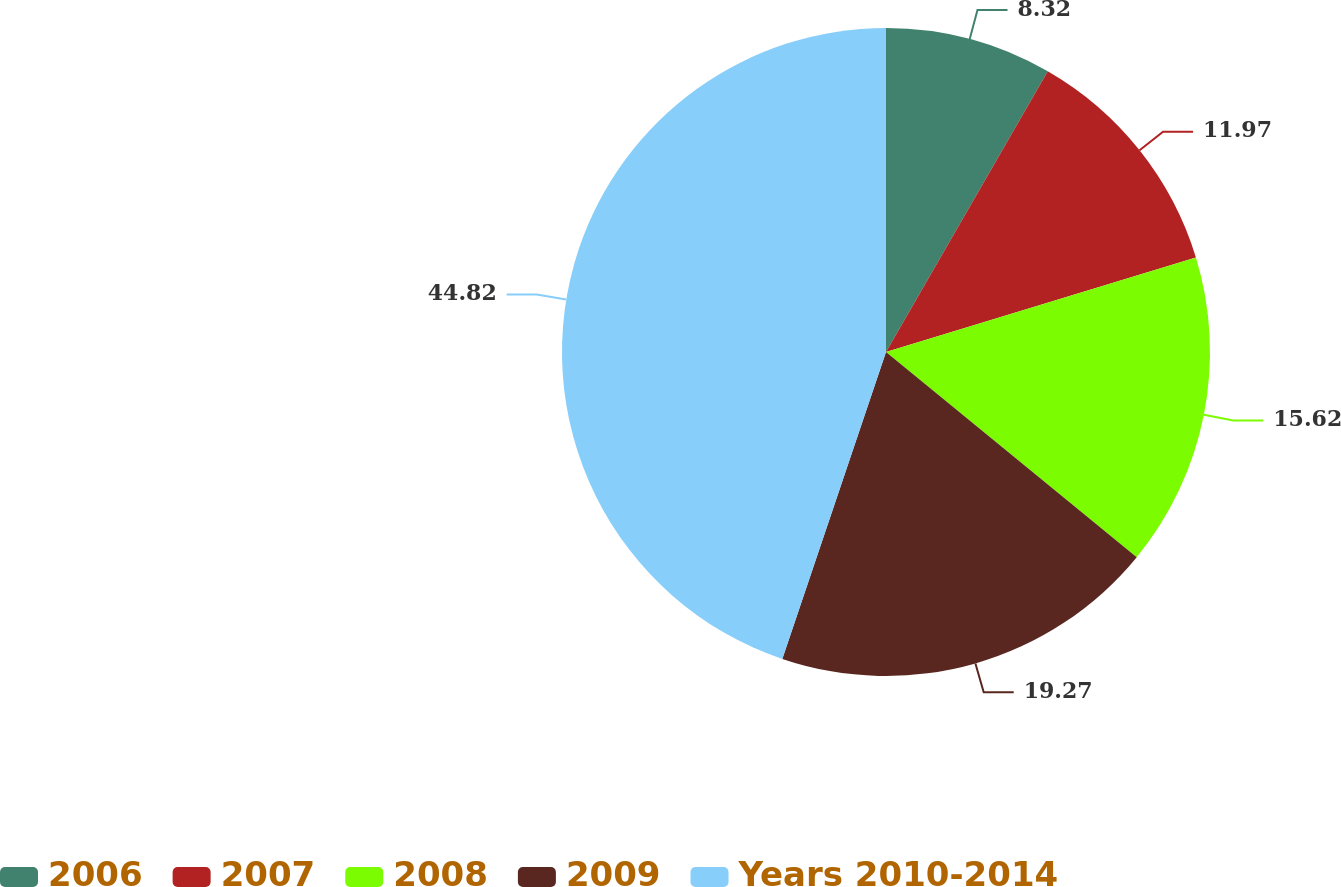Convert chart. <chart><loc_0><loc_0><loc_500><loc_500><pie_chart><fcel>2006<fcel>2007<fcel>2008<fcel>2009<fcel>Years 2010-2014<nl><fcel>8.32%<fcel>11.97%<fcel>15.62%<fcel>19.27%<fcel>44.81%<nl></chart> 